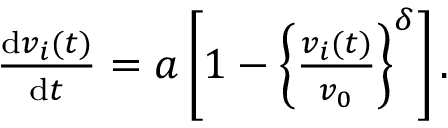<formula> <loc_0><loc_0><loc_500><loc_500>\begin{array} { r } { \frac { d v _ { i } ( t ) } { d t } = a \left [ 1 - \left \{ \frac { v _ { i } ( t ) } { v _ { 0 } } \right \} ^ { \delta } \right ] . } \end{array}</formula> 